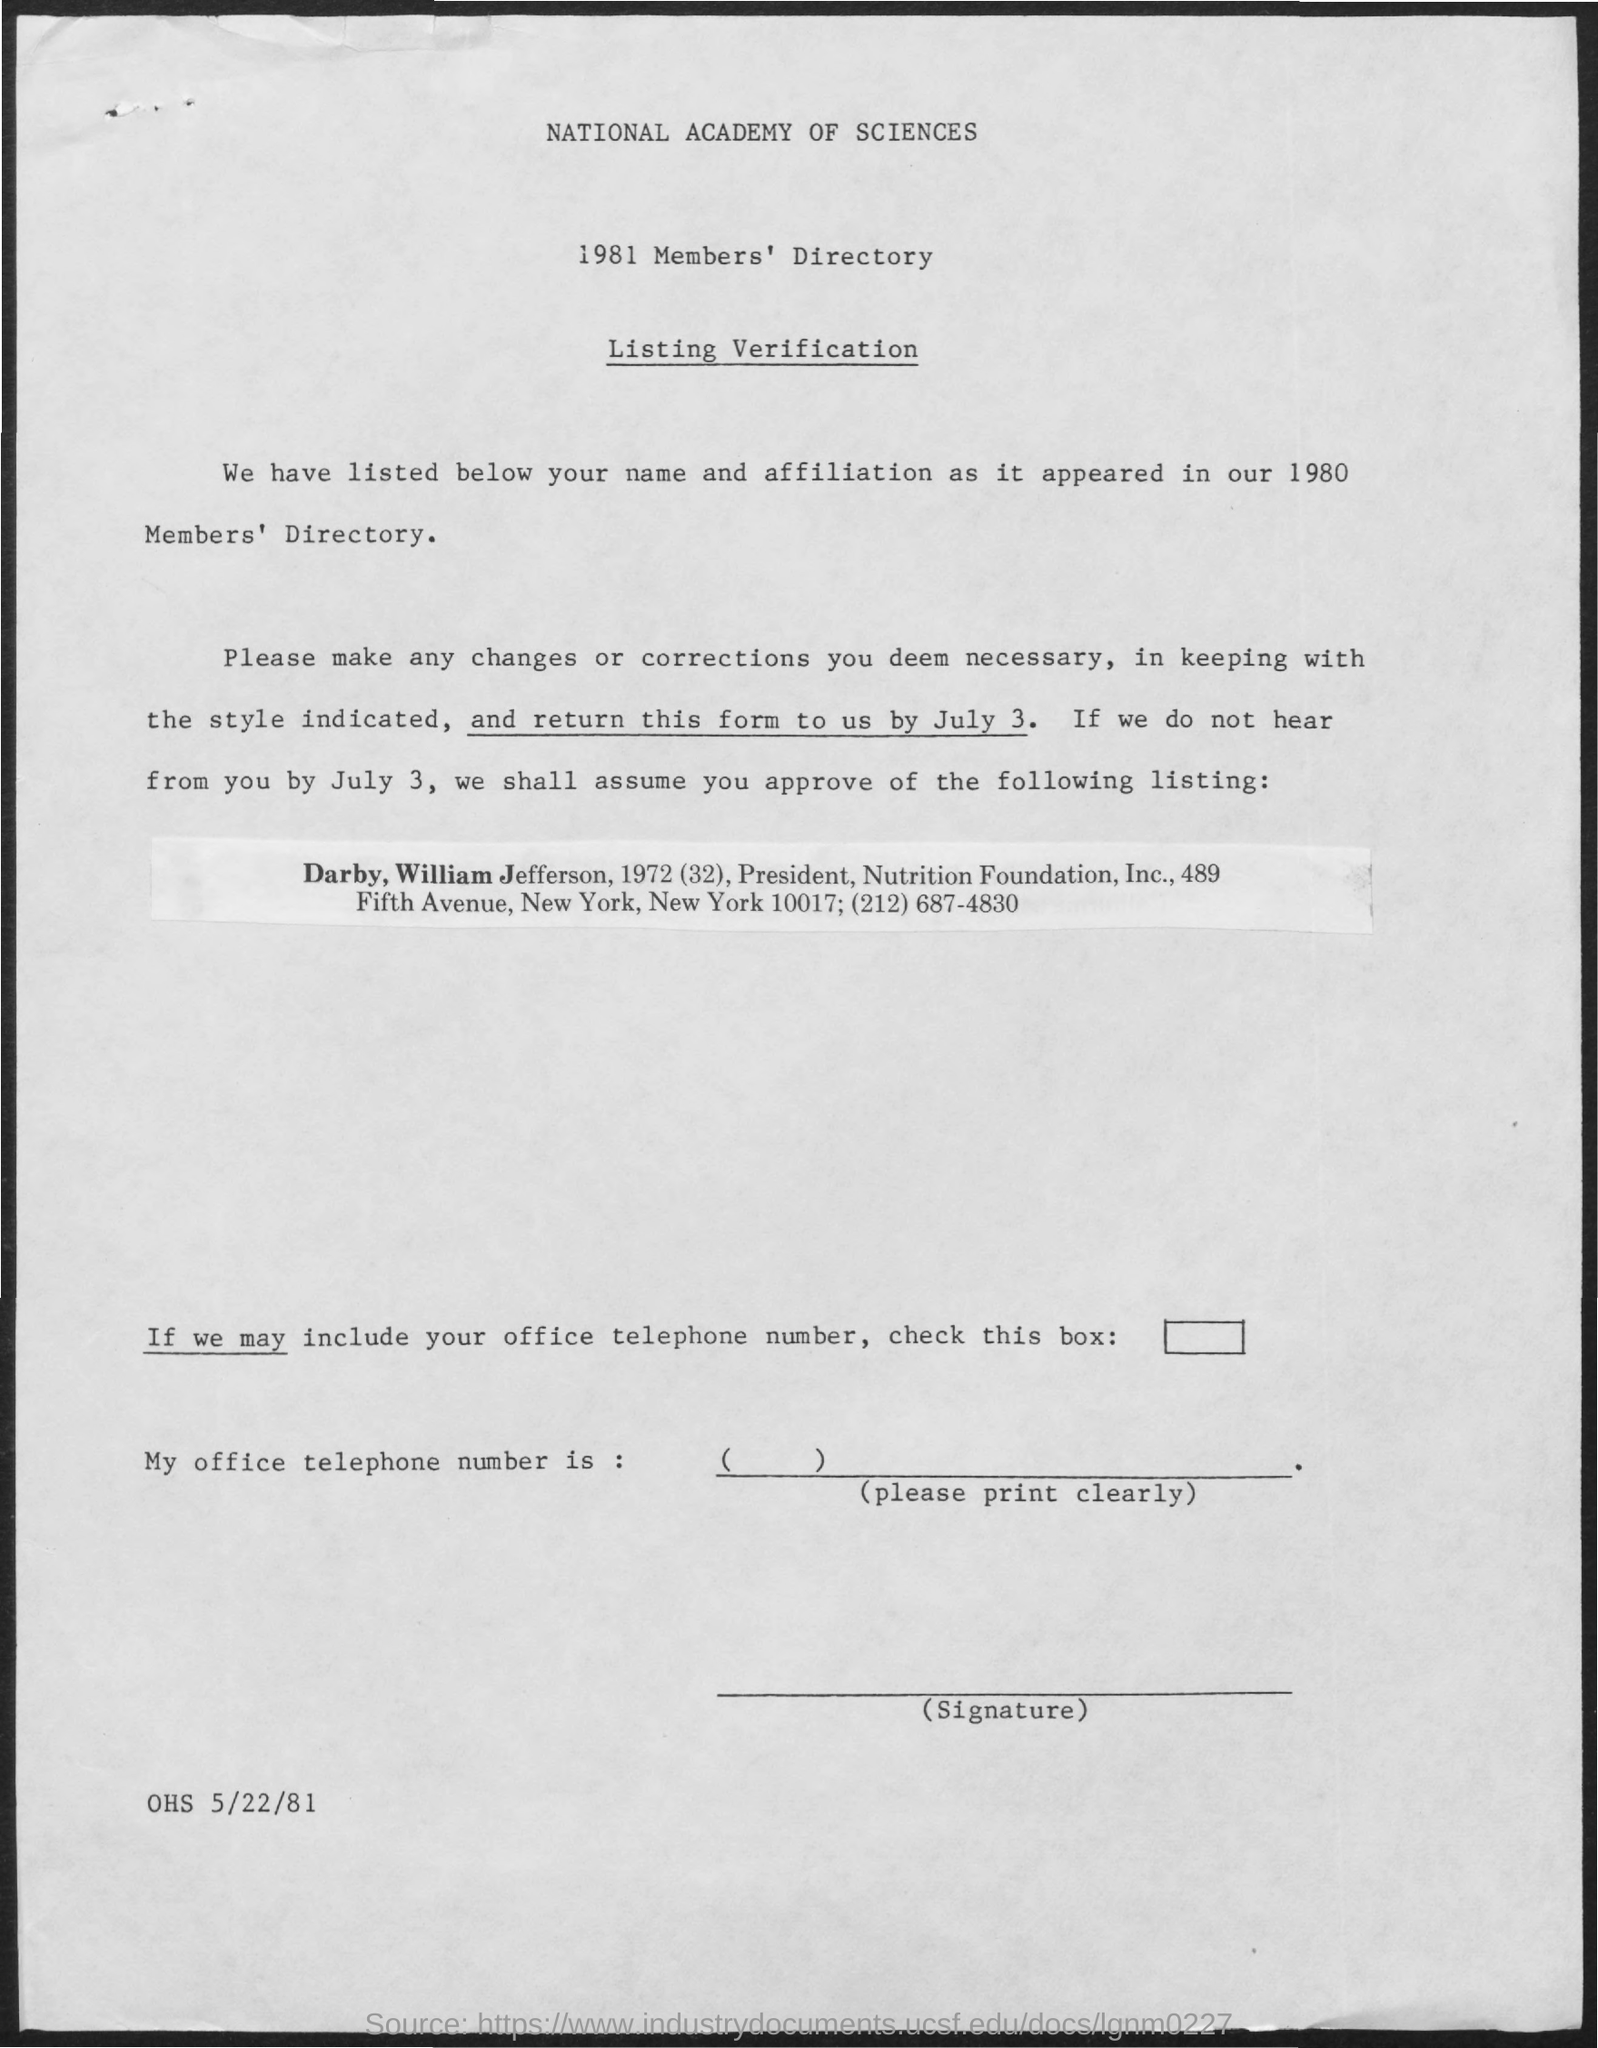What is the first title in the document?
Offer a terse response. National Academy of Sciences. What is the second title in the document?
Your answer should be very brief. 1981 Members' Directory. What is the third title in the document?
Make the answer very short. Listing Verification. 